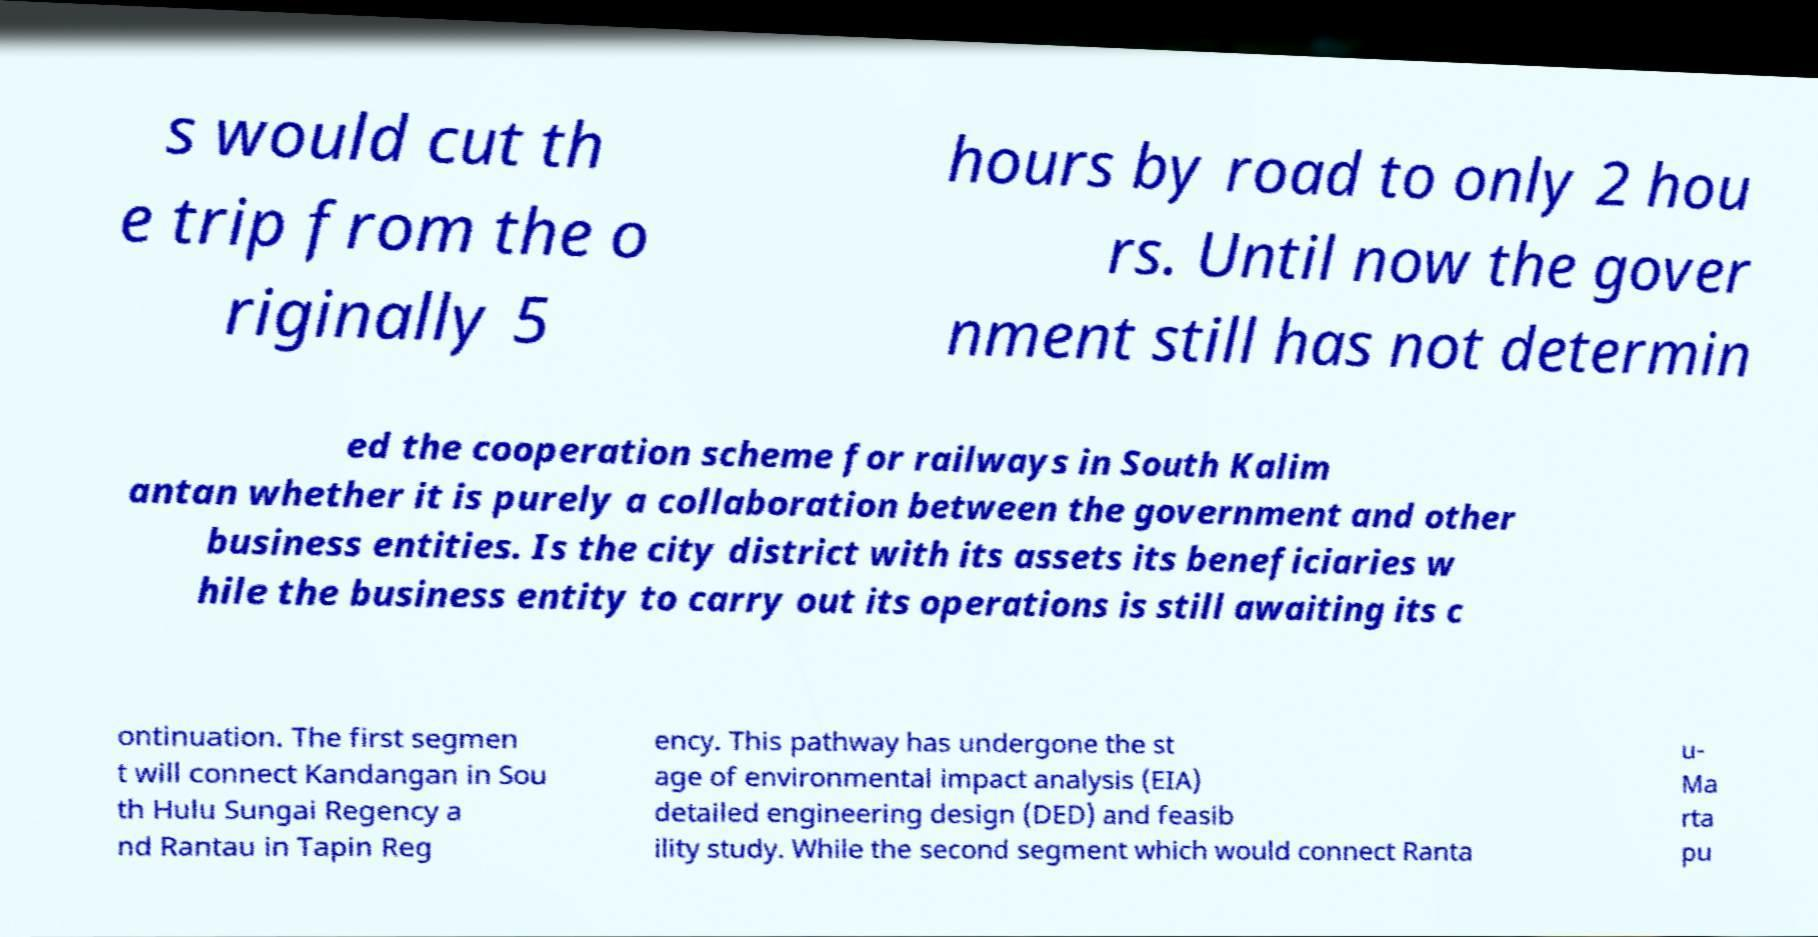Can you accurately transcribe the text from the provided image for me? s would cut th e trip from the o riginally 5 hours by road to only 2 hou rs. Until now the gover nment still has not determin ed the cooperation scheme for railways in South Kalim antan whether it is purely a collaboration between the government and other business entities. Is the city district with its assets its beneficiaries w hile the business entity to carry out its operations is still awaiting its c ontinuation. The first segmen t will connect Kandangan in Sou th Hulu Sungai Regency a nd Rantau in Tapin Reg ency. This pathway has undergone the st age of environmental impact analysis (EIA) detailed engineering design (DED) and feasib ility study. While the second segment which would connect Ranta u- Ma rta pu 